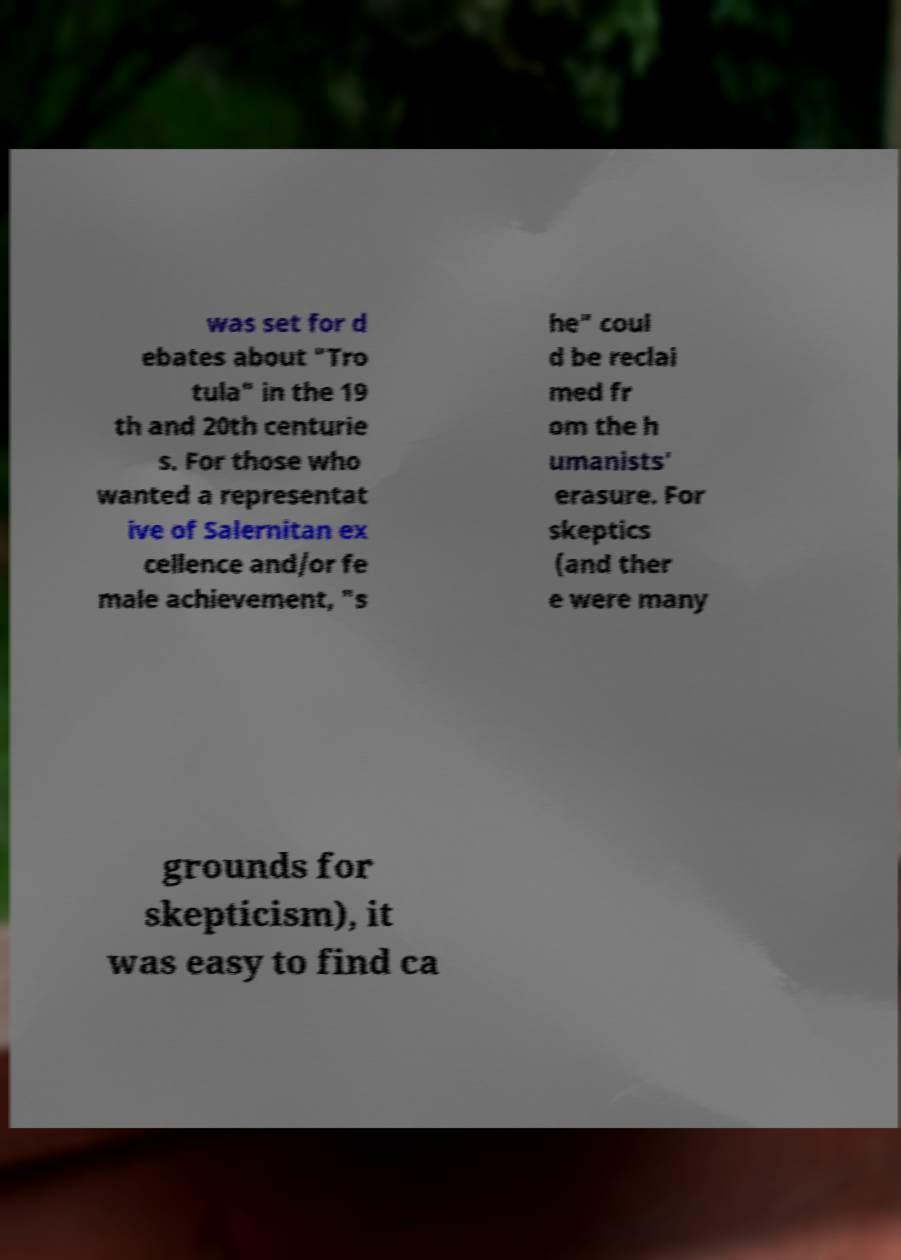Could you assist in decoding the text presented in this image and type it out clearly? was set for d ebates about "Tro tula" in the 19 th and 20th centurie s. For those who wanted a representat ive of Salernitan ex cellence and/or fe male achievement, "s he" coul d be reclai med fr om the h umanists' erasure. For skeptics (and ther e were many grounds for skepticism), it was easy to find ca 